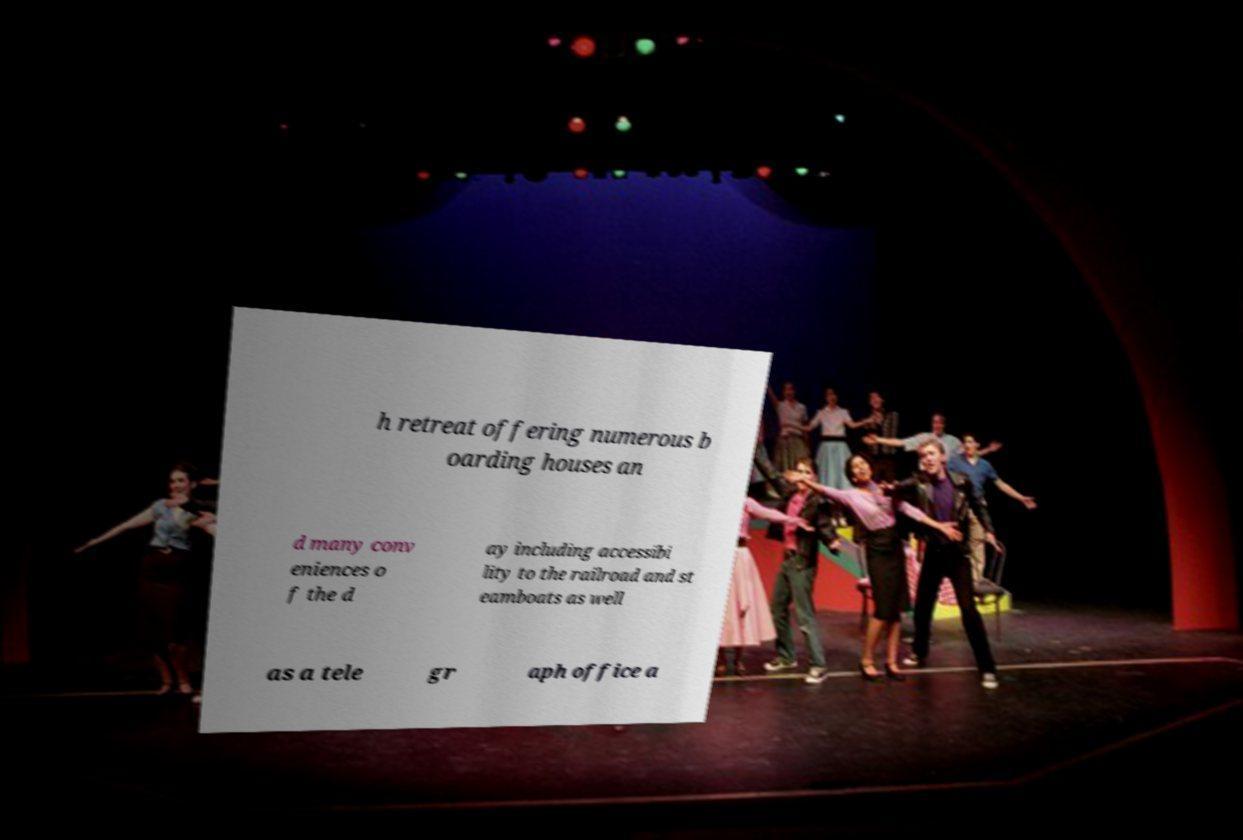Could you assist in decoding the text presented in this image and type it out clearly? h retreat offering numerous b oarding houses an d many conv eniences o f the d ay including accessibi lity to the railroad and st eamboats as well as a tele gr aph office a 